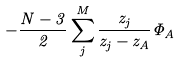<formula> <loc_0><loc_0><loc_500><loc_500>- \frac { N - 3 } { 2 } \sum _ { j } ^ { M } \frac { z _ { j } } { z _ { j } - z _ { A } } \Phi _ { A }</formula> 